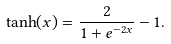Convert formula to latex. <formula><loc_0><loc_0><loc_500><loc_500>\tanh ( x ) = \frac { 2 } { 1 + e ^ { - 2 x } } - 1 .</formula> 